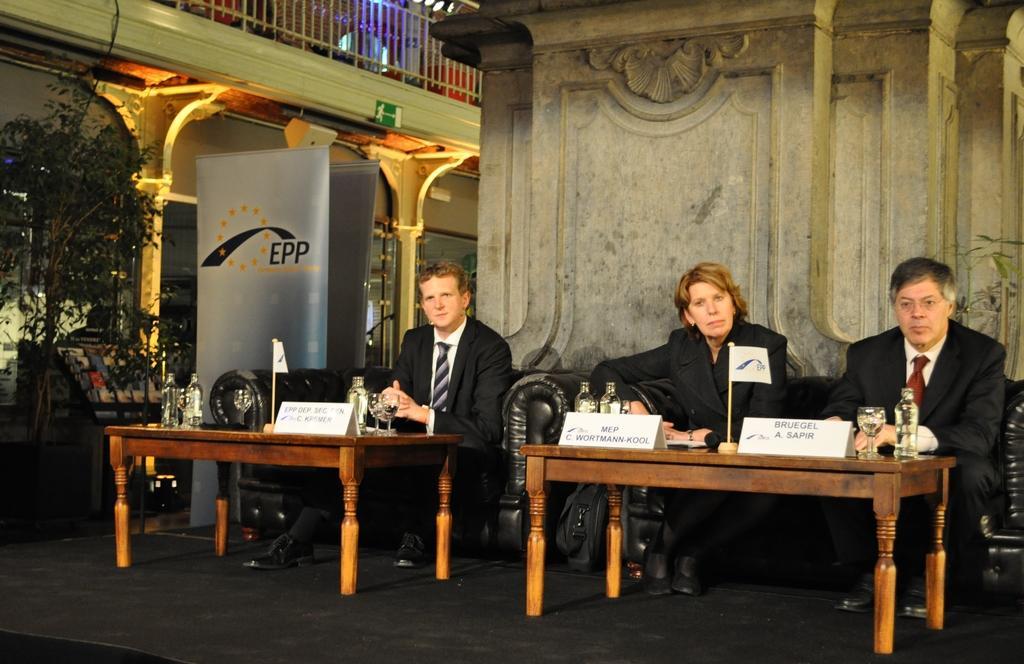Please provide a concise description of this image. The image there is a meeting being held,there are two tables and some name boards,a flag, bottles on the table, in front of the table there are three people sitting, to the left side before the table a man is sitting,to the right side a man and women are sitting in front of the second table, in the background there is a big poster and some trees beside that and also a wall. 